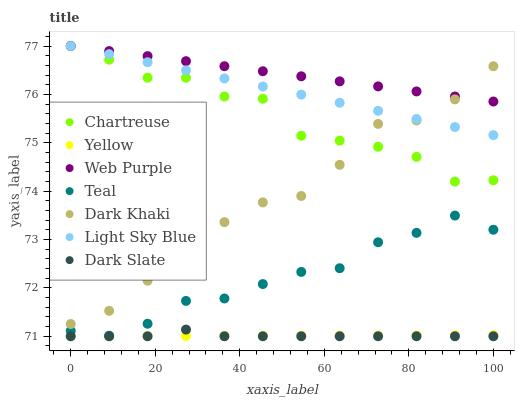Does Yellow have the minimum area under the curve?
Answer yes or no. Yes. Does Web Purple have the maximum area under the curve?
Answer yes or no. Yes. Does Dark Khaki have the minimum area under the curve?
Answer yes or no. No. Does Dark Khaki have the maximum area under the curve?
Answer yes or no. No. Is Web Purple the smoothest?
Answer yes or no. Yes. Is Dark Khaki the roughest?
Answer yes or no. Yes. Is Yellow the smoothest?
Answer yes or no. No. Is Yellow the roughest?
Answer yes or no. No. Does Yellow have the lowest value?
Answer yes or no. Yes. Does Dark Khaki have the lowest value?
Answer yes or no. No. Does Light Sky Blue have the highest value?
Answer yes or no. Yes. Does Dark Khaki have the highest value?
Answer yes or no. No. Is Dark Slate less than Web Purple?
Answer yes or no. Yes. Is Chartreuse greater than Yellow?
Answer yes or no. Yes. Does Chartreuse intersect Light Sky Blue?
Answer yes or no. Yes. Is Chartreuse less than Light Sky Blue?
Answer yes or no. No. Is Chartreuse greater than Light Sky Blue?
Answer yes or no. No. Does Dark Slate intersect Web Purple?
Answer yes or no. No. 